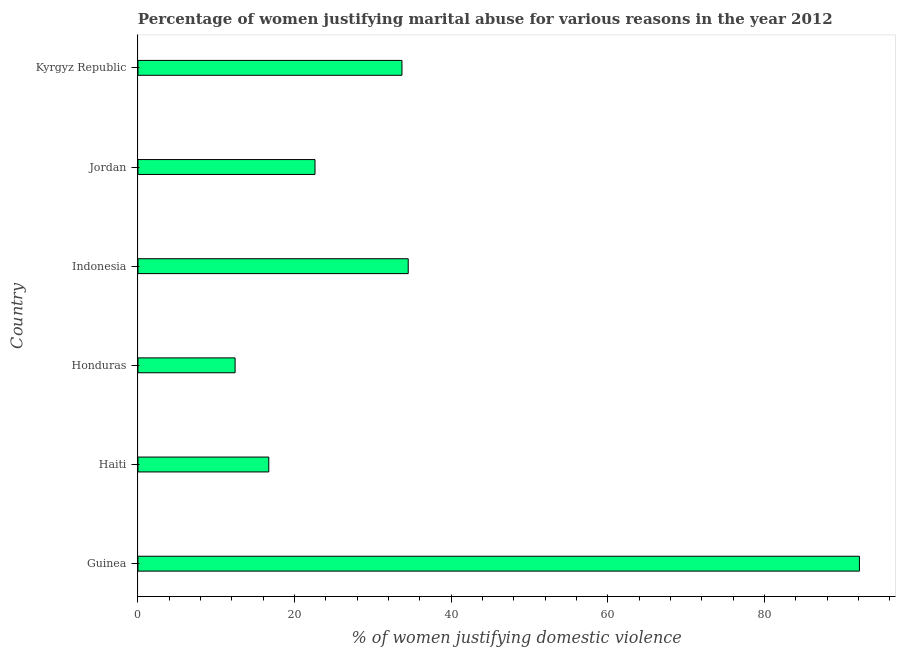Does the graph contain grids?
Your answer should be compact. No. What is the title of the graph?
Offer a terse response. Percentage of women justifying marital abuse for various reasons in the year 2012. What is the label or title of the X-axis?
Ensure brevity in your answer.  % of women justifying domestic violence. What is the label or title of the Y-axis?
Offer a terse response. Country. What is the percentage of women justifying marital abuse in Kyrgyz Republic?
Provide a short and direct response. 33.7. Across all countries, what is the maximum percentage of women justifying marital abuse?
Offer a terse response. 92.1. In which country was the percentage of women justifying marital abuse maximum?
Offer a very short reply. Guinea. In which country was the percentage of women justifying marital abuse minimum?
Provide a short and direct response. Honduras. What is the sum of the percentage of women justifying marital abuse?
Your answer should be very brief. 212. What is the difference between the percentage of women justifying marital abuse in Guinea and Jordan?
Give a very brief answer. 69.5. What is the average percentage of women justifying marital abuse per country?
Offer a very short reply. 35.33. What is the median percentage of women justifying marital abuse?
Offer a terse response. 28.15. In how many countries, is the percentage of women justifying marital abuse greater than 28 %?
Offer a very short reply. 3. What is the ratio of the percentage of women justifying marital abuse in Indonesia to that in Jordan?
Ensure brevity in your answer.  1.53. Is the percentage of women justifying marital abuse in Guinea less than that in Jordan?
Provide a short and direct response. No. Is the difference between the percentage of women justifying marital abuse in Haiti and Jordan greater than the difference between any two countries?
Your answer should be compact. No. What is the difference between the highest and the second highest percentage of women justifying marital abuse?
Give a very brief answer. 57.6. What is the difference between the highest and the lowest percentage of women justifying marital abuse?
Offer a terse response. 79.7. How many bars are there?
Your answer should be very brief. 6. How many countries are there in the graph?
Keep it short and to the point. 6. What is the difference between two consecutive major ticks on the X-axis?
Your response must be concise. 20. What is the % of women justifying domestic violence of Guinea?
Your answer should be very brief. 92.1. What is the % of women justifying domestic violence of Haiti?
Offer a very short reply. 16.7. What is the % of women justifying domestic violence in Indonesia?
Provide a short and direct response. 34.5. What is the % of women justifying domestic violence in Jordan?
Offer a terse response. 22.6. What is the % of women justifying domestic violence in Kyrgyz Republic?
Keep it short and to the point. 33.7. What is the difference between the % of women justifying domestic violence in Guinea and Haiti?
Offer a terse response. 75.4. What is the difference between the % of women justifying domestic violence in Guinea and Honduras?
Give a very brief answer. 79.7. What is the difference between the % of women justifying domestic violence in Guinea and Indonesia?
Your answer should be compact. 57.6. What is the difference between the % of women justifying domestic violence in Guinea and Jordan?
Ensure brevity in your answer.  69.5. What is the difference between the % of women justifying domestic violence in Guinea and Kyrgyz Republic?
Your answer should be compact. 58.4. What is the difference between the % of women justifying domestic violence in Haiti and Honduras?
Your response must be concise. 4.3. What is the difference between the % of women justifying domestic violence in Haiti and Indonesia?
Ensure brevity in your answer.  -17.8. What is the difference between the % of women justifying domestic violence in Haiti and Jordan?
Offer a very short reply. -5.9. What is the difference between the % of women justifying domestic violence in Haiti and Kyrgyz Republic?
Your response must be concise. -17. What is the difference between the % of women justifying domestic violence in Honduras and Indonesia?
Make the answer very short. -22.1. What is the difference between the % of women justifying domestic violence in Honduras and Kyrgyz Republic?
Make the answer very short. -21.3. What is the difference between the % of women justifying domestic violence in Indonesia and Kyrgyz Republic?
Your answer should be very brief. 0.8. What is the difference between the % of women justifying domestic violence in Jordan and Kyrgyz Republic?
Provide a succinct answer. -11.1. What is the ratio of the % of women justifying domestic violence in Guinea to that in Haiti?
Keep it short and to the point. 5.51. What is the ratio of the % of women justifying domestic violence in Guinea to that in Honduras?
Ensure brevity in your answer.  7.43. What is the ratio of the % of women justifying domestic violence in Guinea to that in Indonesia?
Provide a succinct answer. 2.67. What is the ratio of the % of women justifying domestic violence in Guinea to that in Jordan?
Ensure brevity in your answer.  4.08. What is the ratio of the % of women justifying domestic violence in Guinea to that in Kyrgyz Republic?
Ensure brevity in your answer.  2.73. What is the ratio of the % of women justifying domestic violence in Haiti to that in Honduras?
Ensure brevity in your answer.  1.35. What is the ratio of the % of women justifying domestic violence in Haiti to that in Indonesia?
Provide a short and direct response. 0.48. What is the ratio of the % of women justifying domestic violence in Haiti to that in Jordan?
Offer a very short reply. 0.74. What is the ratio of the % of women justifying domestic violence in Haiti to that in Kyrgyz Republic?
Offer a very short reply. 0.5. What is the ratio of the % of women justifying domestic violence in Honduras to that in Indonesia?
Your answer should be very brief. 0.36. What is the ratio of the % of women justifying domestic violence in Honduras to that in Jordan?
Offer a very short reply. 0.55. What is the ratio of the % of women justifying domestic violence in Honduras to that in Kyrgyz Republic?
Give a very brief answer. 0.37. What is the ratio of the % of women justifying domestic violence in Indonesia to that in Jordan?
Provide a short and direct response. 1.53. What is the ratio of the % of women justifying domestic violence in Jordan to that in Kyrgyz Republic?
Offer a very short reply. 0.67. 